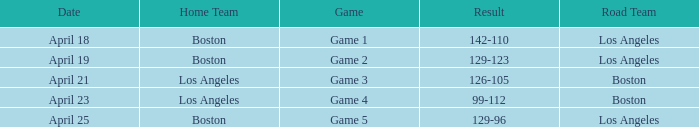WHAT IS THE HOME TEAM ON APRIL 25? Boston. I'm looking to parse the entire table for insights. Could you assist me with that? {'header': ['Date', 'Home Team', 'Game', 'Result', 'Road Team'], 'rows': [['April 18', 'Boston', 'Game 1', '142-110', 'Los Angeles'], ['April 19', 'Boston', 'Game 2', '129-123', 'Los Angeles'], ['April 21', 'Los Angeles', 'Game 3', '126-105', 'Boston'], ['April 23', 'Los Angeles', 'Game 4', '99-112', 'Boston'], ['April 25', 'Boston', 'Game 5', '129-96', 'Los Angeles']]} 